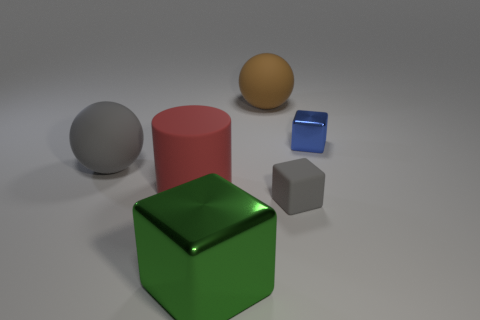Add 3 tiny gray shiny cylinders. How many tiny gray shiny cylinders exist? 3 Add 1 tiny brown cylinders. How many objects exist? 7 Subtract all brown balls. How many balls are left? 1 Subtract all small blocks. How many blocks are left? 1 Subtract 1 gray blocks. How many objects are left? 5 Subtract all cylinders. How many objects are left? 5 Subtract 2 blocks. How many blocks are left? 1 Subtract all blue cubes. Subtract all blue balls. How many cubes are left? 2 Subtract all yellow blocks. How many gray spheres are left? 1 Subtract all spheres. Subtract all small blue metallic things. How many objects are left? 3 